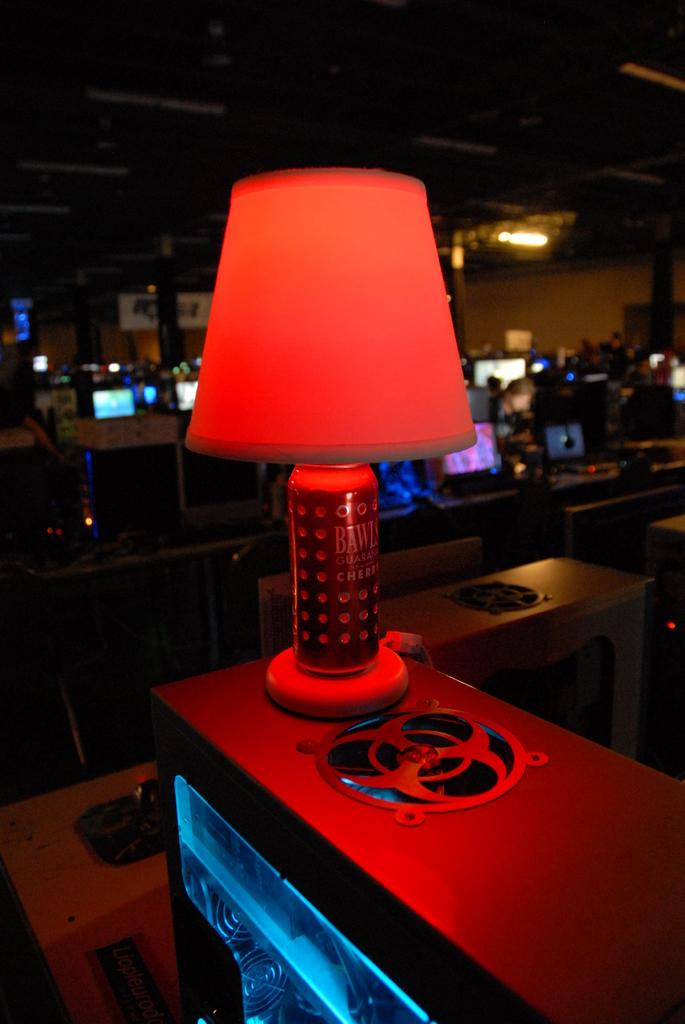What piece of furniture is present in the image? There is a table in the image. What is on the table? There is a table lamp on the table. What can be seen in the background of the image? There are computers on tables in the background. What part of a building is visible in the image? There is a roof visible in the image. What is the source of light at the top of the image? There is a light at the top of the image. What type of drug is being used on the table in the image? There is no drug present in the image; the table has a table lamp on it. 